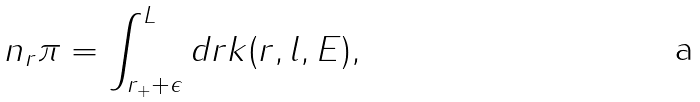Convert formula to latex. <formula><loc_0><loc_0><loc_500><loc_500>n _ { r } \pi = \int _ { r _ { + } + \epsilon } ^ { L } d r k ( r , l , E ) ,</formula> 